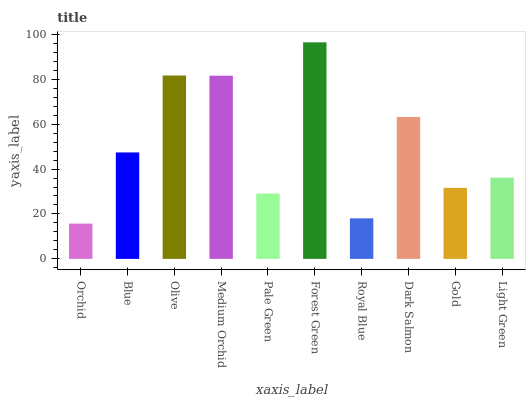Is Orchid the minimum?
Answer yes or no. Yes. Is Forest Green the maximum?
Answer yes or no. Yes. Is Blue the minimum?
Answer yes or no. No. Is Blue the maximum?
Answer yes or no. No. Is Blue greater than Orchid?
Answer yes or no. Yes. Is Orchid less than Blue?
Answer yes or no. Yes. Is Orchid greater than Blue?
Answer yes or no. No. Is Blue less than Orchid?
Answer yes or no. No. Is Blue the high median?
Answer yes or no. Yes. Is Light Green the low median?
Answer yes or no. Yes. Is Royal Blue the high median?
Answer yes or no. No. Is Dark Salmon the low median?
Answer yes or no. No. 